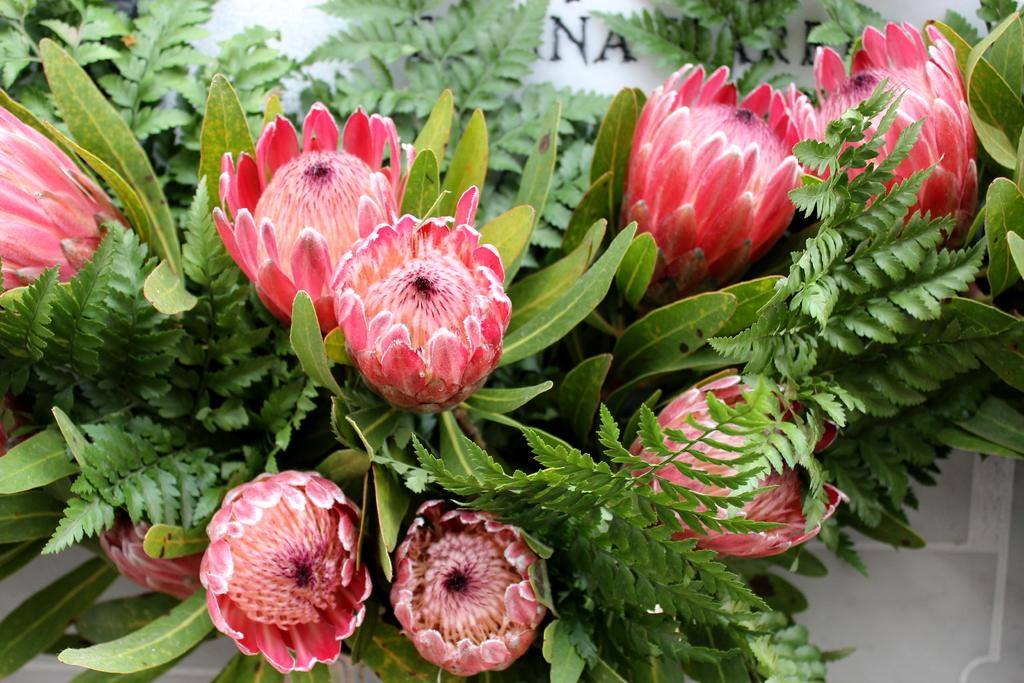What type of plants can be seen in the image? There is a group of flowers in the image. What else can be seen in the image besides the flowers? There are leaves in the image. What is present in the background of the image? There is a board with text in the background of the image. What type of cream can be seen on the chicken in the image? There is no chicken or cream present in the image; it features a group of flowers and leaves with a board in the background. 